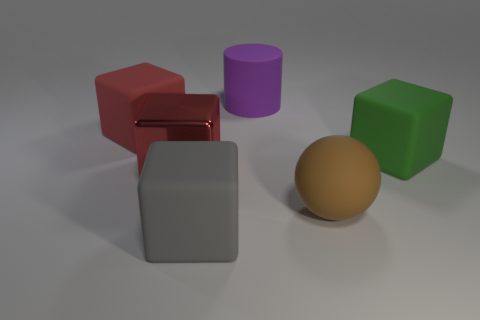There is a matte block that is in front of the cube that is on the right side of the rubber cylinder; what size is it? The matte block in front of the cube, which is situated to the right of the rubber cylinder, is medium-sized in comparison to the other objects present in the image. 